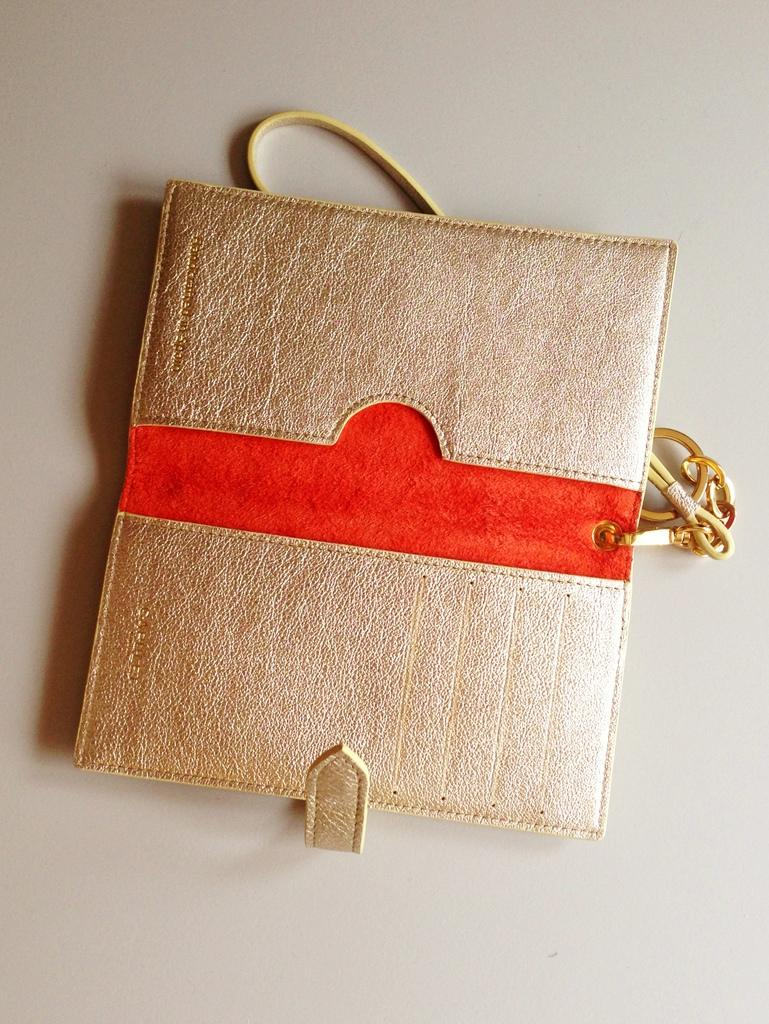What object can be seen in the image? There is a bag in the image. What colors are present on the bag? The bag has silver and red colors. How many boats can be seen in the image? There are no boats present in the image; it only features a bag with silver and red colors. What type of bell is attached to the bag in the image? There is no bell attached to the bag in the image. 